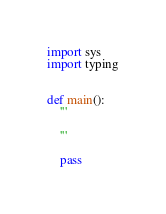Convert code to text. <code><loc_0><loc_0><loc_500><loc_500><_Python_>import sys
import typing


def main():
    ''' 

    '''

    pass
</code> 